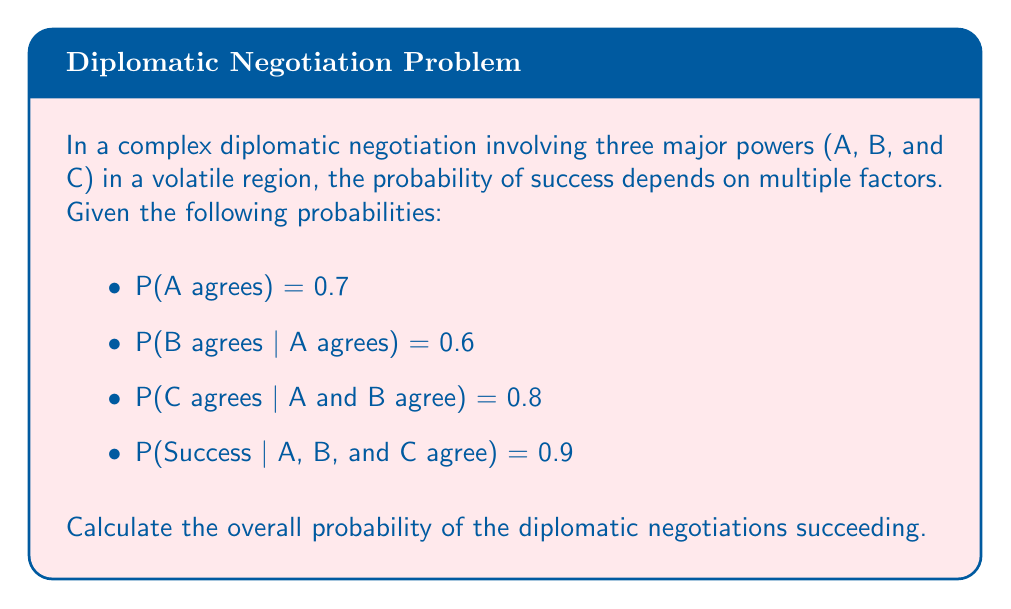Give your solution to this math problem. To solve this problem, we need to use the chain rule of probability. We'll calculate the probability of all events occurring in sequence:

1) First, we need A to agree:
   P(A agrees) = 0.7

2) Given that A agrees, we need B to agree:
   P(B agrees | A agrees) = 0.6

3) Given that both A and B agree, we need C to agree:
   P(C agrees | A and B agree) = 0.8

4) Finally, given that all three agree, we need the negotiations to succeed:
   P(Success | A, B, and C agree) = 0.9

Now, we multiply these probabilities together:

$$P(\text{Success}) = P(A) \cdot P(B|A) \cdot P(C|A,B) \cdot P(S|A,B,C)$$

$$P(\text{Success}) = 0.7 \cdot 0.6 \cdot 0.8 \cdot 0.9$$

$$P(\text{Success}) = 0.3024$$

Therefore, the overall probability of the diplomatic negotiations succeeding is 0.3024 or 30.24%.
Answer: 0.3024 